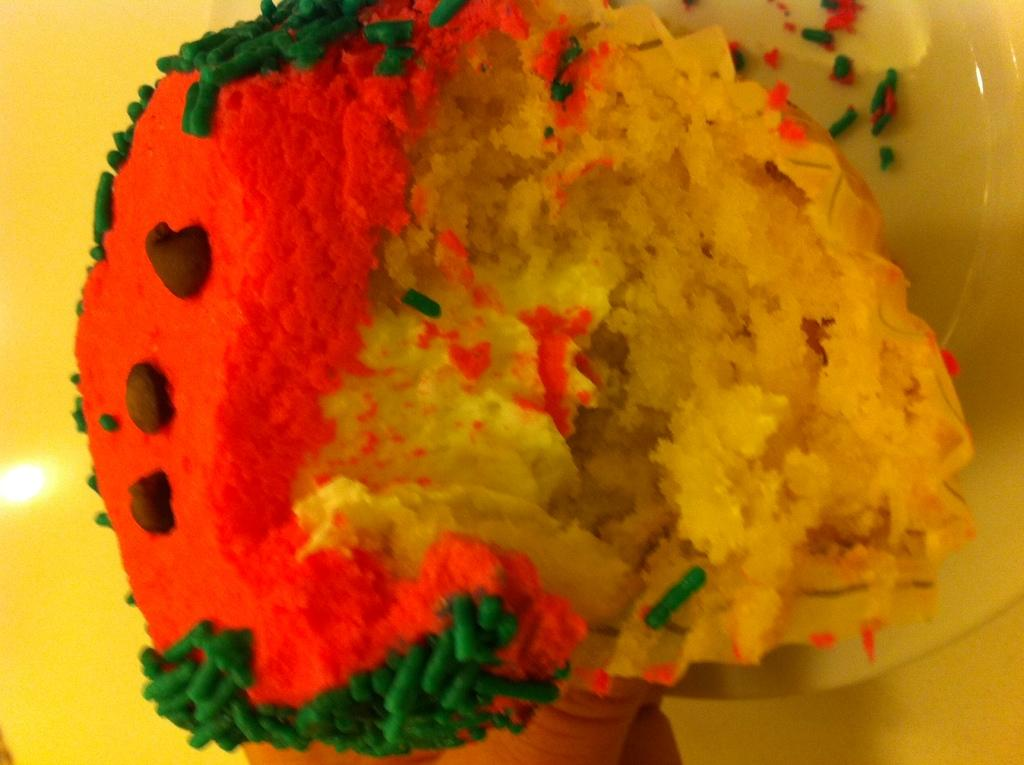What type of dessert is featured in the image? There is a colorful cupcake in the image. What type of hate can be seen in the image? There is no hate present in the image; it features a colorful cupcake. What type of vessel is used to transport the cupcake in the image? There is no vessel present in the image, as the cupcake is not being transported. 